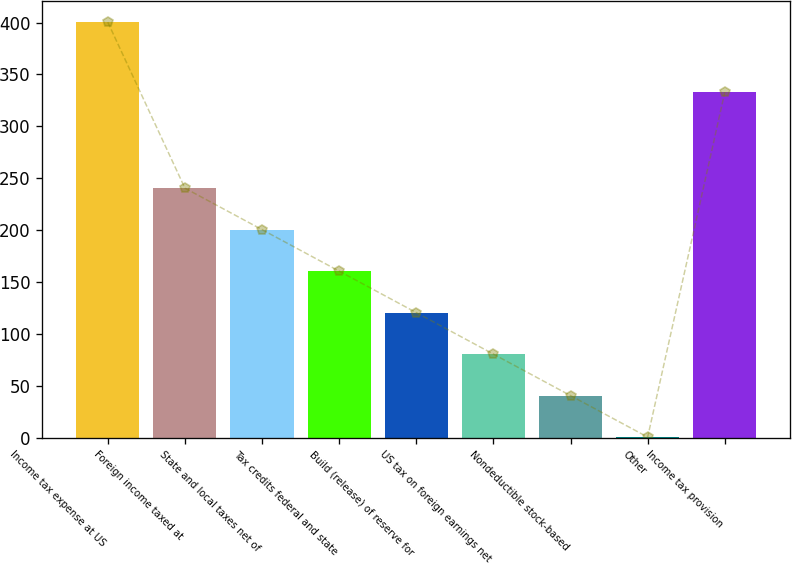Convert chart to OTSL. <chart><loc_0><loc_0><loc_500><loc_500><bar_chart><fcel>Income tax expense at US<fcel>Foreign income taxed at<fcel>State and local taxes net of<fcel>Tax credits federal and state<fcel>Build (release) of reserve for<fcel>US tax on foreign earnings net<fcel>Nondeductible stock-based<fcel>Other<fcel>Income tax provision<nl><fcel>400.4<fcel>240.4<fcel>200.4<fcel>160.4<fcel>120.4<fcel>80.4<fcel>40.4<fcel>0.4<fcel>332.9<nl></chart> 